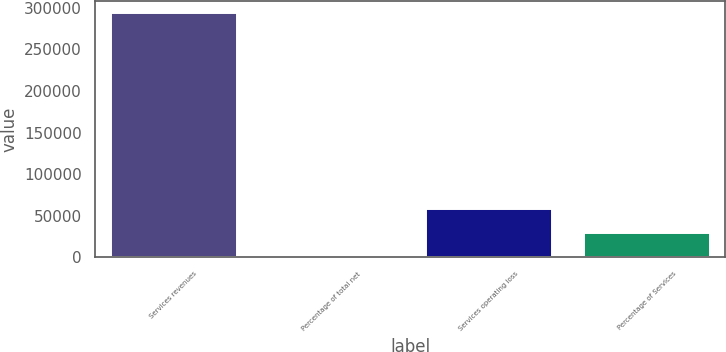<chart> <loc_0><loc_0><loc_500><loc_500><bar_chart><fcel>Services revenues<fcel>Percentage of total net<fcel>Services operating loss<fcel>Percentage of Services<nl><fcel>293226<fcel>6<fcel>58650<fcel>29328<nl></chart> 